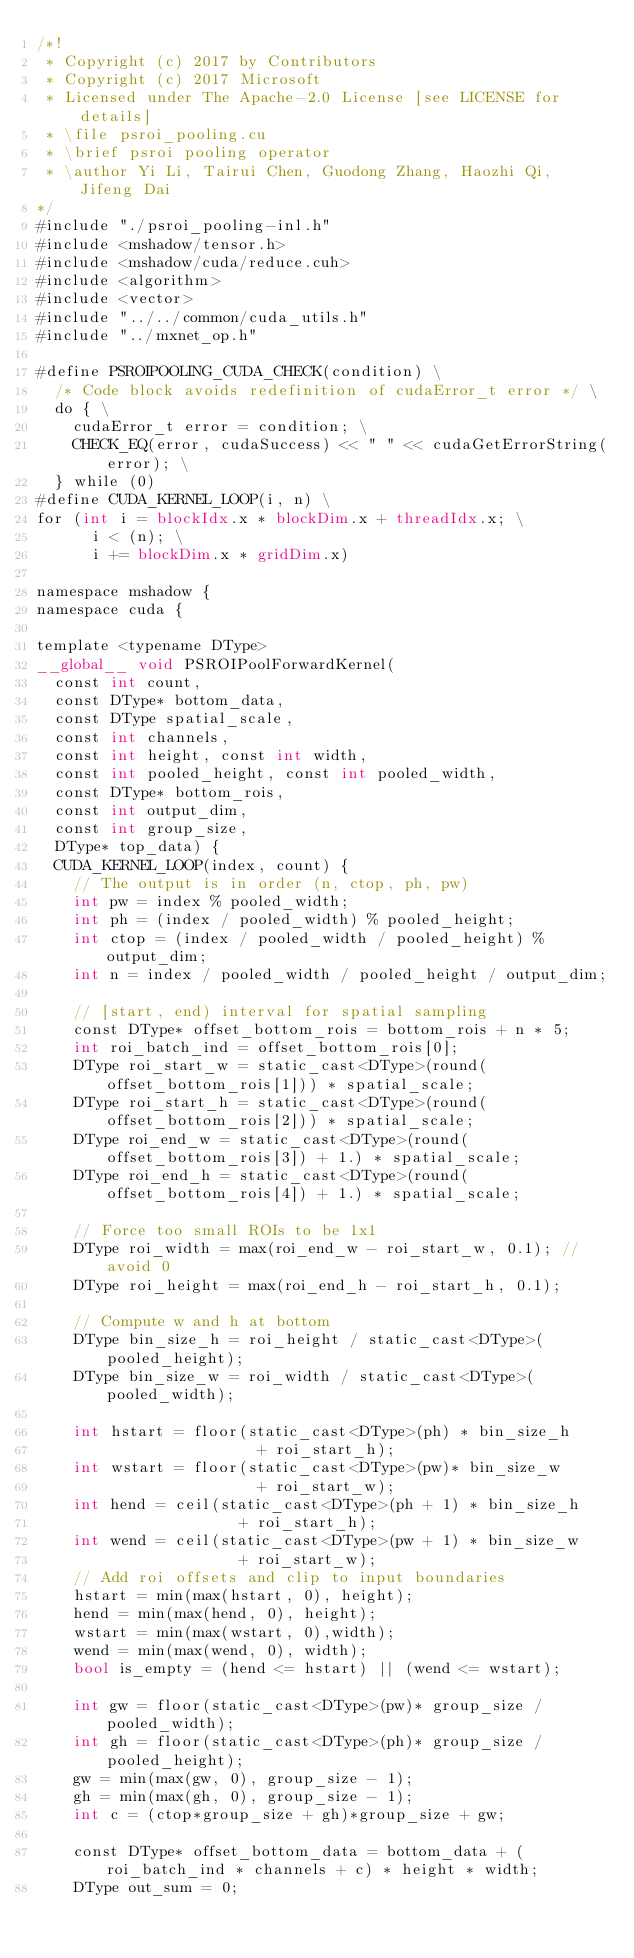<code> <loc_0><loc_0><loc_500><loc_500><_Cuda_>/*!
 * Copyright (c) 2017 by Contributors
 * Copyright (c) 2017 Microsoft
 * Licensed under The Apache-2.0 License [see LICENSE for details]
 * \file psroi_pooling.cu
 * \brief psroi pooling operator
 * \author Yi Li, Tairui Chen, Guodong Zhang, Haozhi Qi, Jifeng Dai
*/
#include "./psroi_pooling-inl.h"
#include <mshadow/tensor.h>
#include <mshadow/cuda/reduce.cuh>
#include <algorithm>
#include <vector>
#include "../../common/cuda_utils.h"
#include "../mxnet_op.h"

#define PSROIPOOLING_CUDA_CHECK(condition) \
  /* Code block avoids redefinition of cudaError_t error */ \
  do { \
    cudaError_t error = condition; \
    CHECK_EQ(error, cudaSuccess) << " " << cudaGetErrorString(error); \
  } while (0)
#define CUDA_KERNEL_LOOP(i, n) \
for (int i = blockIdx.x * blockDim.x + threadIdx.x; \
      i < (n); \
      i += blockDim.x * gridDim.x)

namespace mshadow {
namespace cuda {

template <typename DType>
__global__ void PSROIPoolForwardKernel(
  const int count,
  const DType* bottom_data,
  const DType spatial_scale,
  const int channels,
  const int height, const int width,
  const int pooled_height, const int pooled_width,
  const DType* bottom_rois,
  const int output_dim,
  const int group_size,
  DType* top_data) {
  CUDA_KERNEL_LOOP(index, count) {
    // The output is in order (n, ctop, ph, pw)
    int pw = index % pooled_width;
    int ph = (index / pooled_width) % pooled_height;
    int ctop = (index / pooled_width / pooled_height) % output_dim;
    int n = index / pooled_width / pooled_height / output_dim;

    // [start, end) interval for spatial sampling
    const DType* offset_bottom_rois = bottom_rois + n * 5;
    int roi_batch_ind = offset_bottom_rois[0];
    DType roi_start_w = static_cast<DType>(round(offset_bottom_rois[1])) * spatial_scale;
    DType roi_start_h = static_cast<DType>(round(offset_bottom_rois[2])) * spatial_scale;
    DType roi_end_w = static_cast<DType>(round(offset_bottom_rois[3]) + 1.) * spatial_scale;
    DType roi_end_h = static_cast<DType>(round(offset_bottom_rois[4]) + 1.) * spatial_scale;

    // Force too small ROIs to be 1x1
    DType roi_width = max(roi_end_w - roi_start_w, 0.1); //avoid 0
    DType roi_height = max(roi_end_h - roi_start_h, 0.1);

    // Compute w and h at bottom
    DType bin_size_h = roi_height / static_cast<DType>(pooled_height);
    DType bin_size_w = roi_width / static_cast<DType>(pooled_width);

    int hstart = floor(static_cast<DType>(ph) * bin_size_h
                        + roi_start_h);
    int wstart = floor(static_cast<DType>(pw)* bin_size_w
                        + roi_start_w);
    int hend = ceil(static_cast<DType>(ph + 1) * bin_size_h
                      + roi_start_h);
    int wend = ceil(static_cast<DType>(pw + 1) * bin_size_w
                      + roi_start_w);
    // Add roi offsets and clip to input boundaries
    hstart = min(max(hstart, 0), height);
    hend = min(max(hend, 0), height);
    wstart = min(max(wstart, 0),width);
    wend = min(max(wend, 0), width);
    bool is_empty = (hend <= hstart) || (wend <= wstart);

    int gw = floor(static_cast<DType>(pw)* group_size / pooled_width);
    int gh = floor(static_cast<DType>(ph)* group_size / pooled_height);
    gw = min(max(gw, 0), group_size - 1);
    gh = min(max(gh, 0), group_size - 1);
    int c = (ctop*group_size + gh)*group_size + gw;

    const DType* offset_bottom_data = bottom_data + (roi_batch_ind * channels + c) * height * width;
    DType out_sum = 0;</code> 